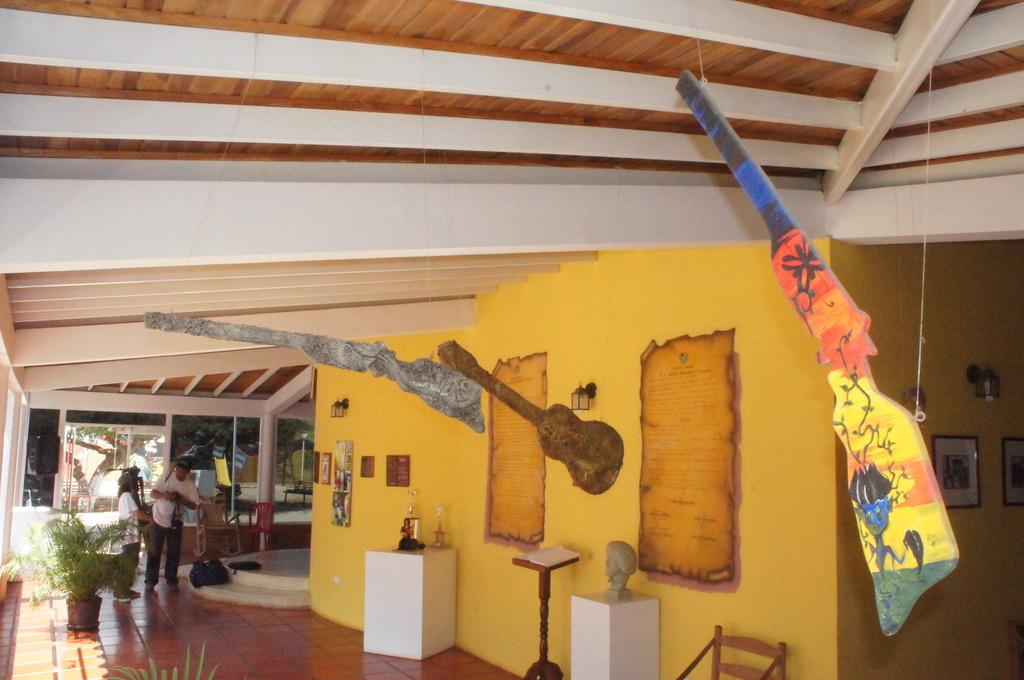How many people are in the image? There are two persons standing in the image. What is the surface they are standing on? The persons are standing on the floor. What object can be seen in the image that might be used for carrying items? There is a bag in the image. What type of living organisms are present in the image? There are house plants in the image. What can be seen in the image that might be used for reading or learning? There is a book in the image. What type of furniture is present in the image? There are chairs in the image. What is on the wall in the image? There is a wall with frames and posters in the image. What is visible in the background of the image? There is a tree visible in the background of the image. What type of tub can be seen in the image? There is no tub present in the image. How many mittens are visible on the persons in the image? There are no mittens visible on the persons in the image. 